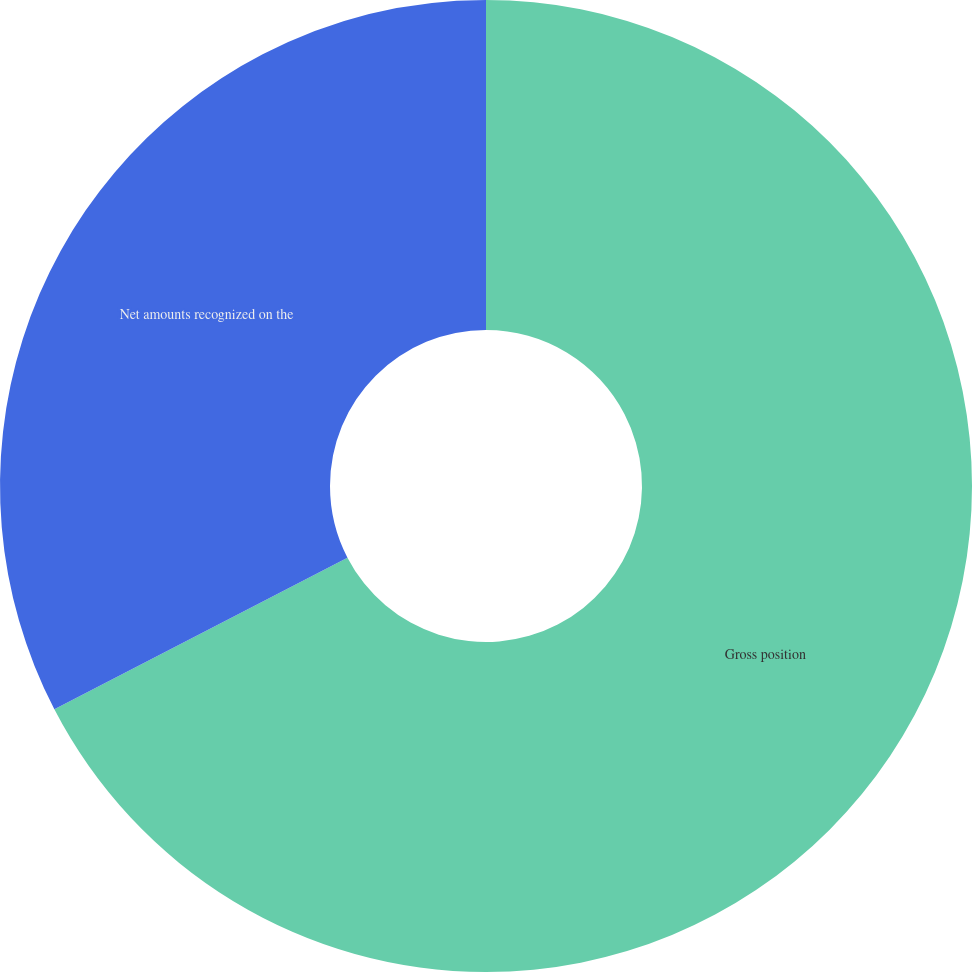Convert chart to OTSL. <chart><loc_0><loc_0><loc_500><loc_500><pie_chart><fcel>Gross position<fcel>Net amounts recognized on the<nl><fcel>67.4%<fcel>32.6%<nl></chart> 